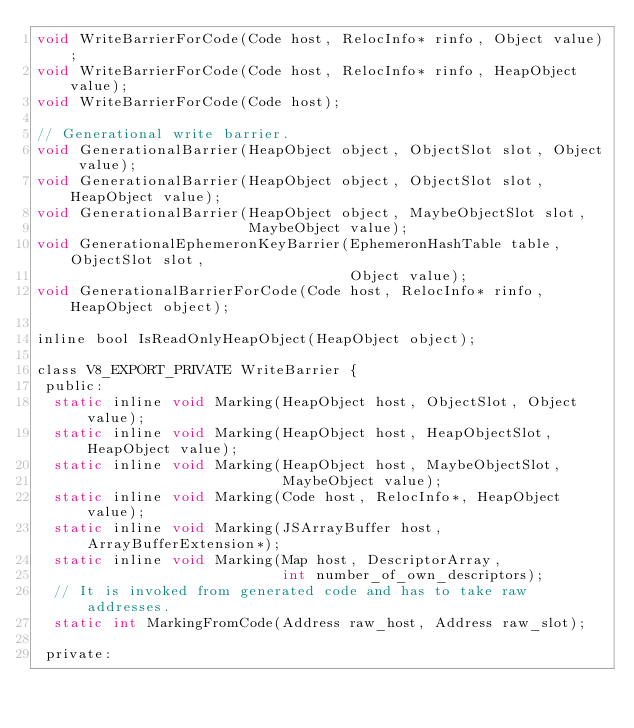<code> <loc_0><loc_0><loc_500><loc_500><_C_>void WriteBarrierForCode(Code host, RelocInfo* rinfo, Object value);
void WriteBarrierForCode(Code host, RelocInfo* rinfo, HeapObject value);
void WriteBarrierForCode(Code host);

// Generational write barrier.
void GenerationalBarrier(HeapObject object, ObjectSlot slot, Object value);
void GenerationalBarrier(HeapObject object, ObjectSlot slot, HeapObject value);
void GenerationalBarrier(HeapObject object, MaybeObjectSlot slot,
                         MaybeObject value);
void GenerationalEphemeronKeyBarrier(EphemeronHashTable table, ObjectSlot slot,
                                     Object value);
void GenerationalBarrierForCode(Code host, RelocInfo* rinfo, HeapObject object);

inline bool IsReadOnlyHeapObject(HeapObject object);

class V8_EXPORT_PRIVATE WriteBarrier {
 public:
  static inline void Marking(HeapObject host, ObjectSlot, Object value);
  static inline void Marking(HeapObject host, HeapObjectSlot, HeapObject value);
  static inline void Marking(HeapObject host, MaybeObjectSlot,
                             MaybeObject value);
  static inline void Marking(Code host, RelocInfo*, HeapObject value);
  static inline void Marking(JSArrayBuffer host, ArrayBufferExtension*);
  static inline void Marking(Map host, DescriptorArray,
                             int number_of_own_descriptors);
  // It is invoked from generated code and has to take raw addresses.
  static int MarkingFromCode(Address raw_host, Address raw_slot);

 private:</code> 